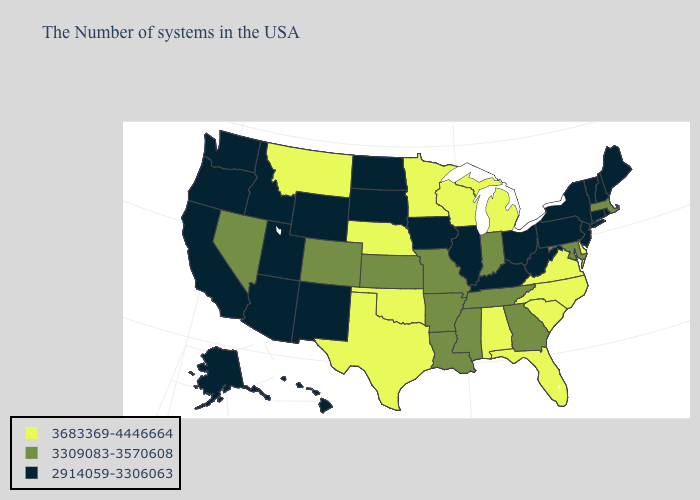What is the value of New Hampshire?
Quick response, please. 2914059-3306063. Does the first symbol in the legend represent the smallest category?
Short answer required. No. What is the value of Louisiana?
Keep it brief. 3309083-3570608. Among the states that border Kansas , does Missouri have the highest value?
Concise answer only. No. Does Florida have the same value as Mississippi?
Quick response, please. No. What is the highest value in states that border New York?
Be succinct. 3309083-3570608. Name the states that have a value in the range 3309083-3570608?
Concise answer only. Massachusetts, Maryland, Georgia, Indiana, Tennessee, Mississippi, Louisiana, Missouri, Arkansas, Kansas, Colorado, Nevada. Name the states that have a value in the range 2914059-3306063?
Short answer required. Maine, Rhode Island, New Hampshire, Vermont, Connecticut, New York, New Jersey, Pennsylvania, West Virginia, Ohio, Kentucky, Illinois, Iowa, South Dakota, North Dakota, Wyoming, New Mexico, Utah, Arizona, Idaho, California, Washington, Oregon, Alaska, Hawaii. Does Massachusetts have the lowest value in the Northeast?
Give a very brief answer. No. What is the highest value in the USA?
Answer briefly. 3683369-4446664. What is the value of Wisconsin?
Give a very brief answer. 3683369-4446664. Which states have the lowest value in the West?
Give a very brief answer. Wyoming, New Mexico, Utah, Arizona, Idaho, California, Washington, Oregon, Alaska, Hawaii. Does Nevada have a higher value than Maryland?
Concise answer only. No. Does Ohio have the lowest value in the USA?
Keep it brief. Yes. 